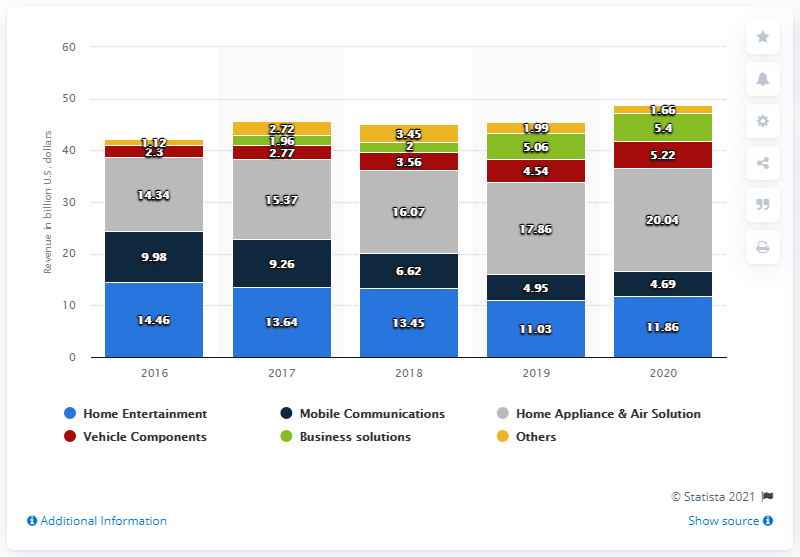Outline some significant characteristics in this image. In 2020, LG Electronics reported home entertainment revenue of approximately 11.86 billion dollars. 